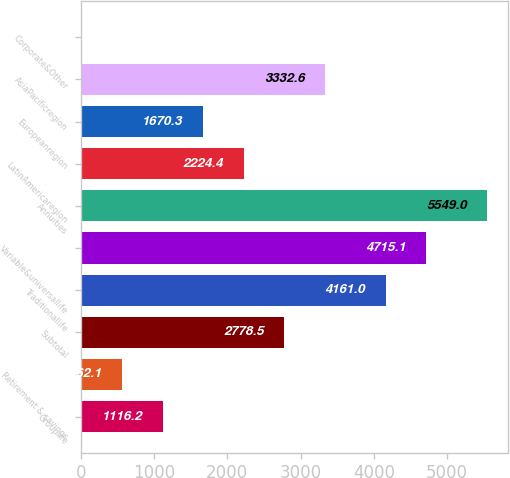<chart> <loc_0><loc_0><loc_500><loc_500><bar_chart><fcel>Grouplife<fcel>Retirement & savings<fcel>Subtotal<fcel>Traditionallife<fcel>Variable&universallife<fcel>Annuities<fcel>LatinAmericaregion<fcel>Europeanregion<fcel>AsiaPacificregion<fcel>Corporate&Other<nl><fcel>1116.2<fcel>562.1<fcel>2778.5<fcel>4161<fcel>4715.1<fcel>5549<fcel>2224.4<fcel>1670.3<fcel>3332.6<fcel>8<nl></chart> 